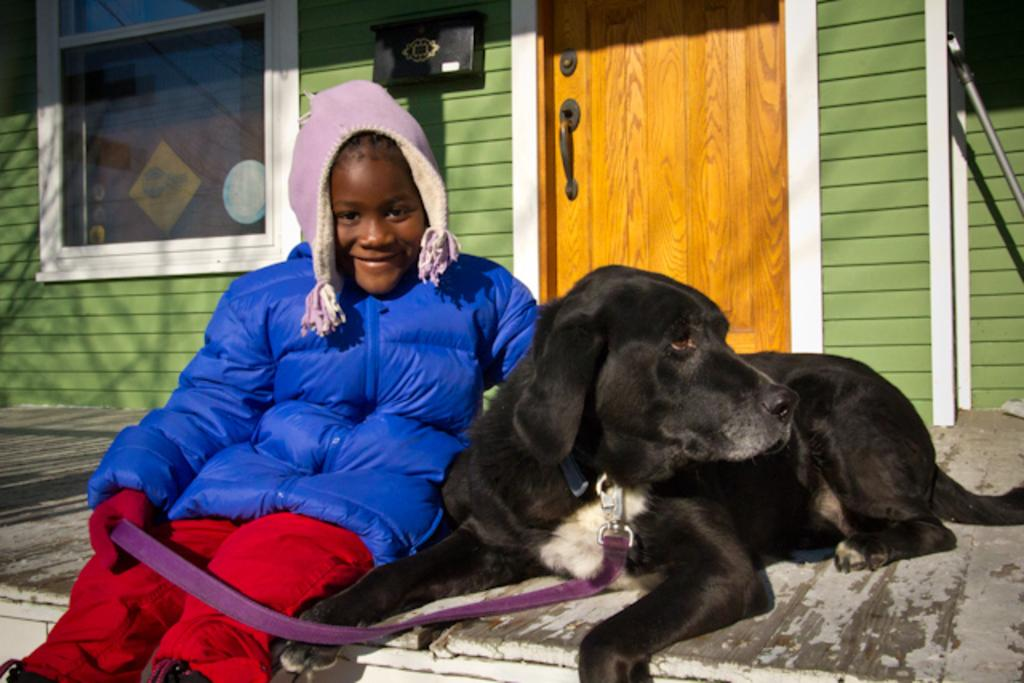What is the main subject of the image? There is a child and a dog in the image. Where are the child and the dog located? Both the child and the dog are on a wooden surface. What can be seen in the background of the image? There is a house visible in the background of the image, which has a window and a door. Are there any other objects or structures in the background? Yes, there is a metal pole and a device on the wall of the house. Can you see any planes flying in the image? No, there are no planes visible in the image. Is there a ghost visible in the image? No, there is no ghost present in the image. 